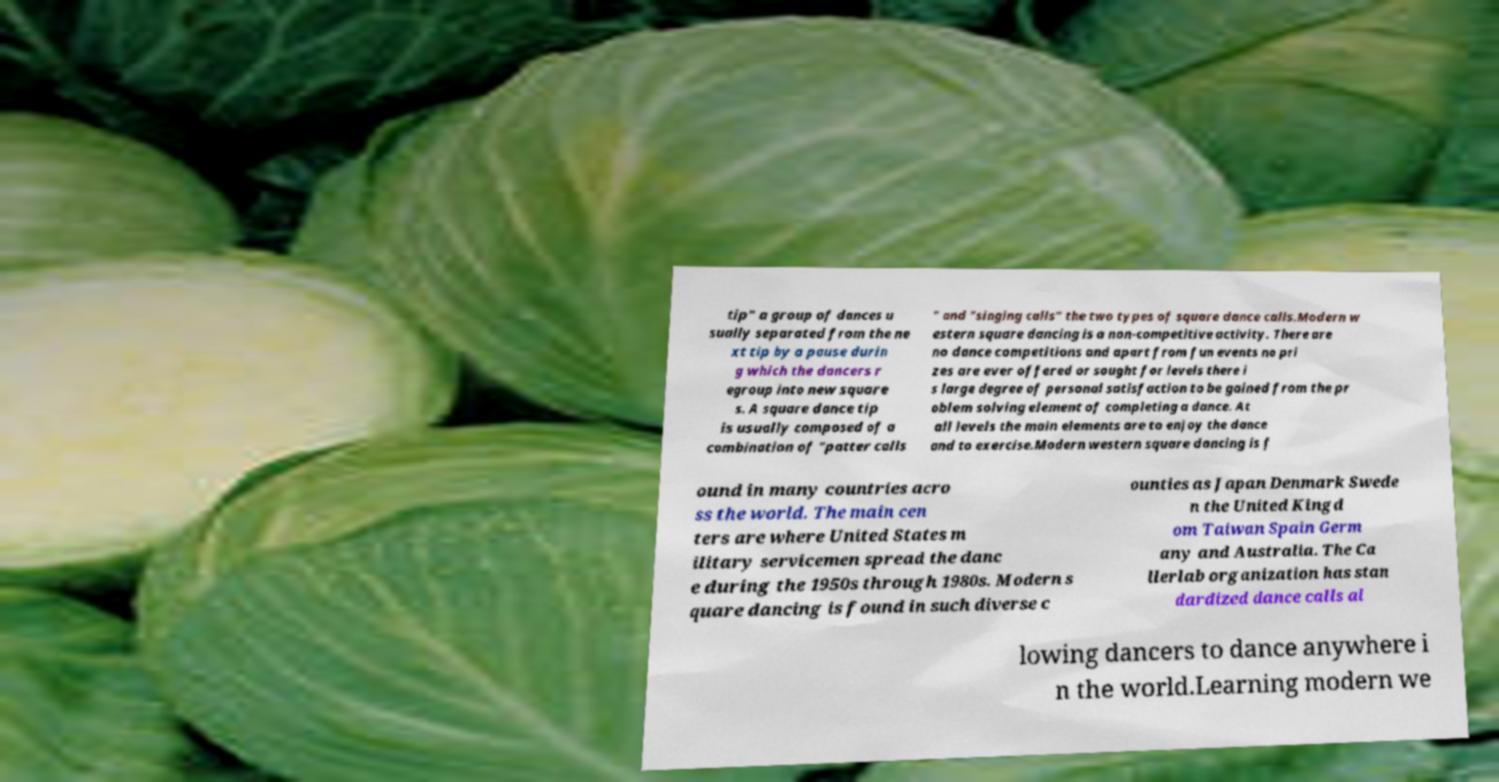What messages or text are displayed in this image? I need them in a readable, typed format. tip" a group of dances u sually separated from the ne xt tip by a pause durin g which the dancers r egroup into new square s. A square dance tip is usually composed of a combination of "patter calls " and "singing calls" the two types of square dance calls.Modern w estern square dancing is a non-competitive activity. There are no dance competitions and apart from fun events no pri zes are ever offered or sought for levels there i s large degree of personal satisfaction to be gained from the pr oblem solving element of completing a dance. At all levels the main elements are to enjoy the dance and to exercise.Modern western square dancing is f ound in many countries acro ss the world. The main cen ters are where United States m ilitary servicemen spread the danc e during the 1950s through 1980s. Modern s quare dancing is found in such diverse c ounties as Japan Denmark Swede n the United Kingd om Taiwan Spain Germ any and Australia. The Ca llerlab organization has stan dardized dance calls al lowing dancers to dance anywhere i n the world.Learning modern we 